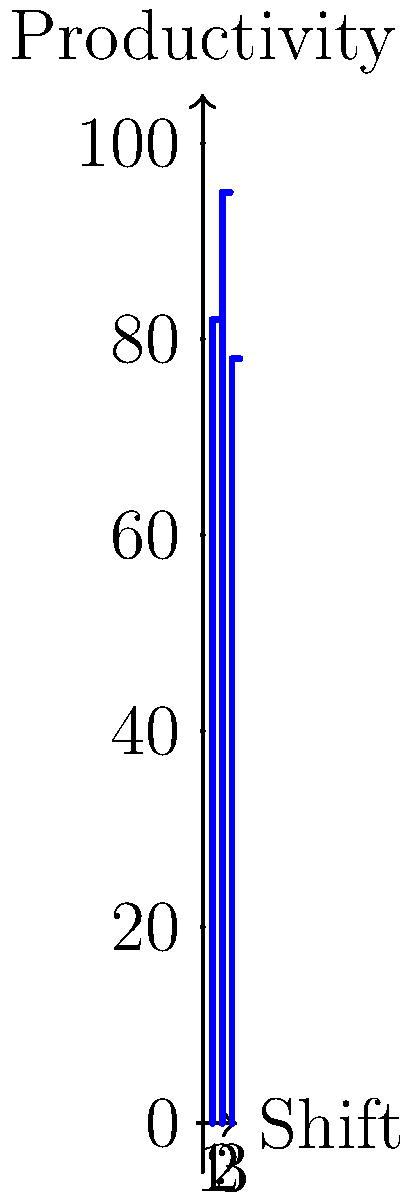The bar graph shows the productivity of garment workers across three different shifts. If the factory manager wants to maximize overall productivity, which two shifts should be prioritized, and what is the combined productivity of these two shifts? To solve this problem, we need to follow these steps:

1. Identify the productivity for each shift:
   Shift 1: 82 units
   Shift 2: 95 units
   Shift 3: 78 units

2. Determine the two shifts with the highest productivity:
   The highest is Shift 2 with 95 units
   The second highest is Shift 1 with 82 units

3. Calculate the combined productivity of these two shifts:
   $95 + 82 = 177$ units

Therefore, to maximize overall productivity, the factory manager should prioritize Shift 2 and Shift 1, which have a combined productivity of 177 units.
Answer: Shifts 2 and 1; 177 units 